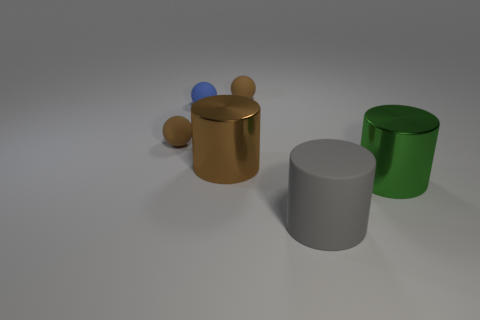How many large gray cylinders are behind the object that is in front of the large metal object that is in front of the large brown cylinder?
Offer a very short reply. 0. How many objects are behind the gray cylinder?
Ensure brevity in your answer.  5. What is the color of the large shiny object right of the tiny brown rubber object that is to the right of the big brown metal cylinder?
Provide a short and direct response. Green. How many other objects are the same material as the blue sphere?
Provide a short and direct response. 3. Are there an equal number of brown cylinders that are to the left of the small blue sphere and tiny red metal blocks?
Your response must be concise. Yes. There is a tiny object on the right side of the metallic object on the left side of the rubber sphere that is on the right side of the big brown metal object; what is it made of?
Your answer should be compact. Rubber. There is a big metallic thing on the right side of the gray cylinder; what color is it?
Your answer should be very brief. Green. There is a metal cylinder on the left side of the cylinder that is in front of the green metal cylinder; what size is it?
Your answer should be very brief. Large. Is the number of metallic objects on the left side of the brown shiny cylinder the same as the number of small matte balls in front of the green metallic cylinder?
Provide a succinct answer. Yes. Is there anything else that has the same size as the rubber cylinder?
Your answer should be compact. Yes. 